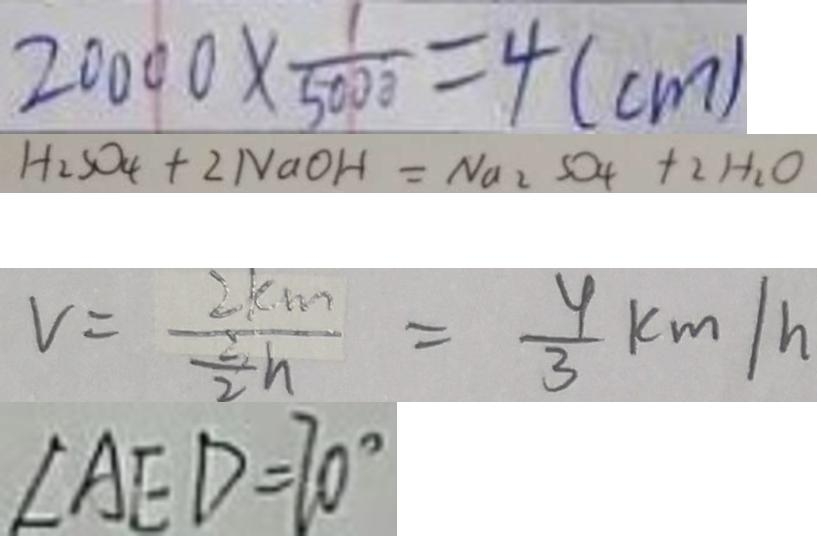<formula> <loc_0><loc_0><loc_500><loc_500>2 0 0 0 0 \times \frac { 1 } { 5 0 0 0 } = 4 ( c m ) 
 H _ { 2 } S O _ { 4 } + 2 N a O H = N a _ { 2 } S O _ { 4 } + 2 H _ { 2 } O 
 V = \frac { 2 k m } { \frac { 3 } { 2 } h } = \frac { 4 } { 3 } k m / h 
 \angle A E D = 7 0 ^ { \circ }</formula> 